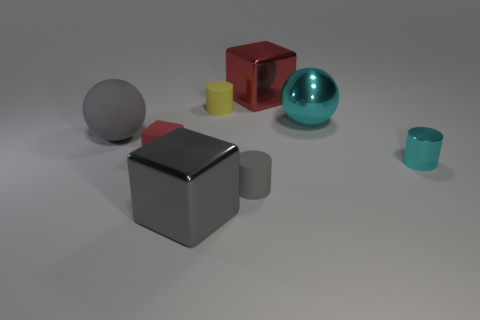Subtract all small metal cylinders. How many cylinders are left? 2 Add 1 green rubber things. How many objects exist? 9 Subtract all red blocks. How many blocks are left? 1 Subtract all cylinders. How many objects are left? 5 Subtract 1 balls. How many balls are left? 1 Subtract all yellow cubes. How many cyan cylinders are left? 1 Subtract all brown metallic spheres. Subtract all red metallic cubes. How many objects are left? 7 Add 8 large blocks. How many large blocks are left? 10 Add 6 tiny red cylinders. How many tiny red cylinders exist? 6 Subtract 2 red blocks. How many objects are left? 6 